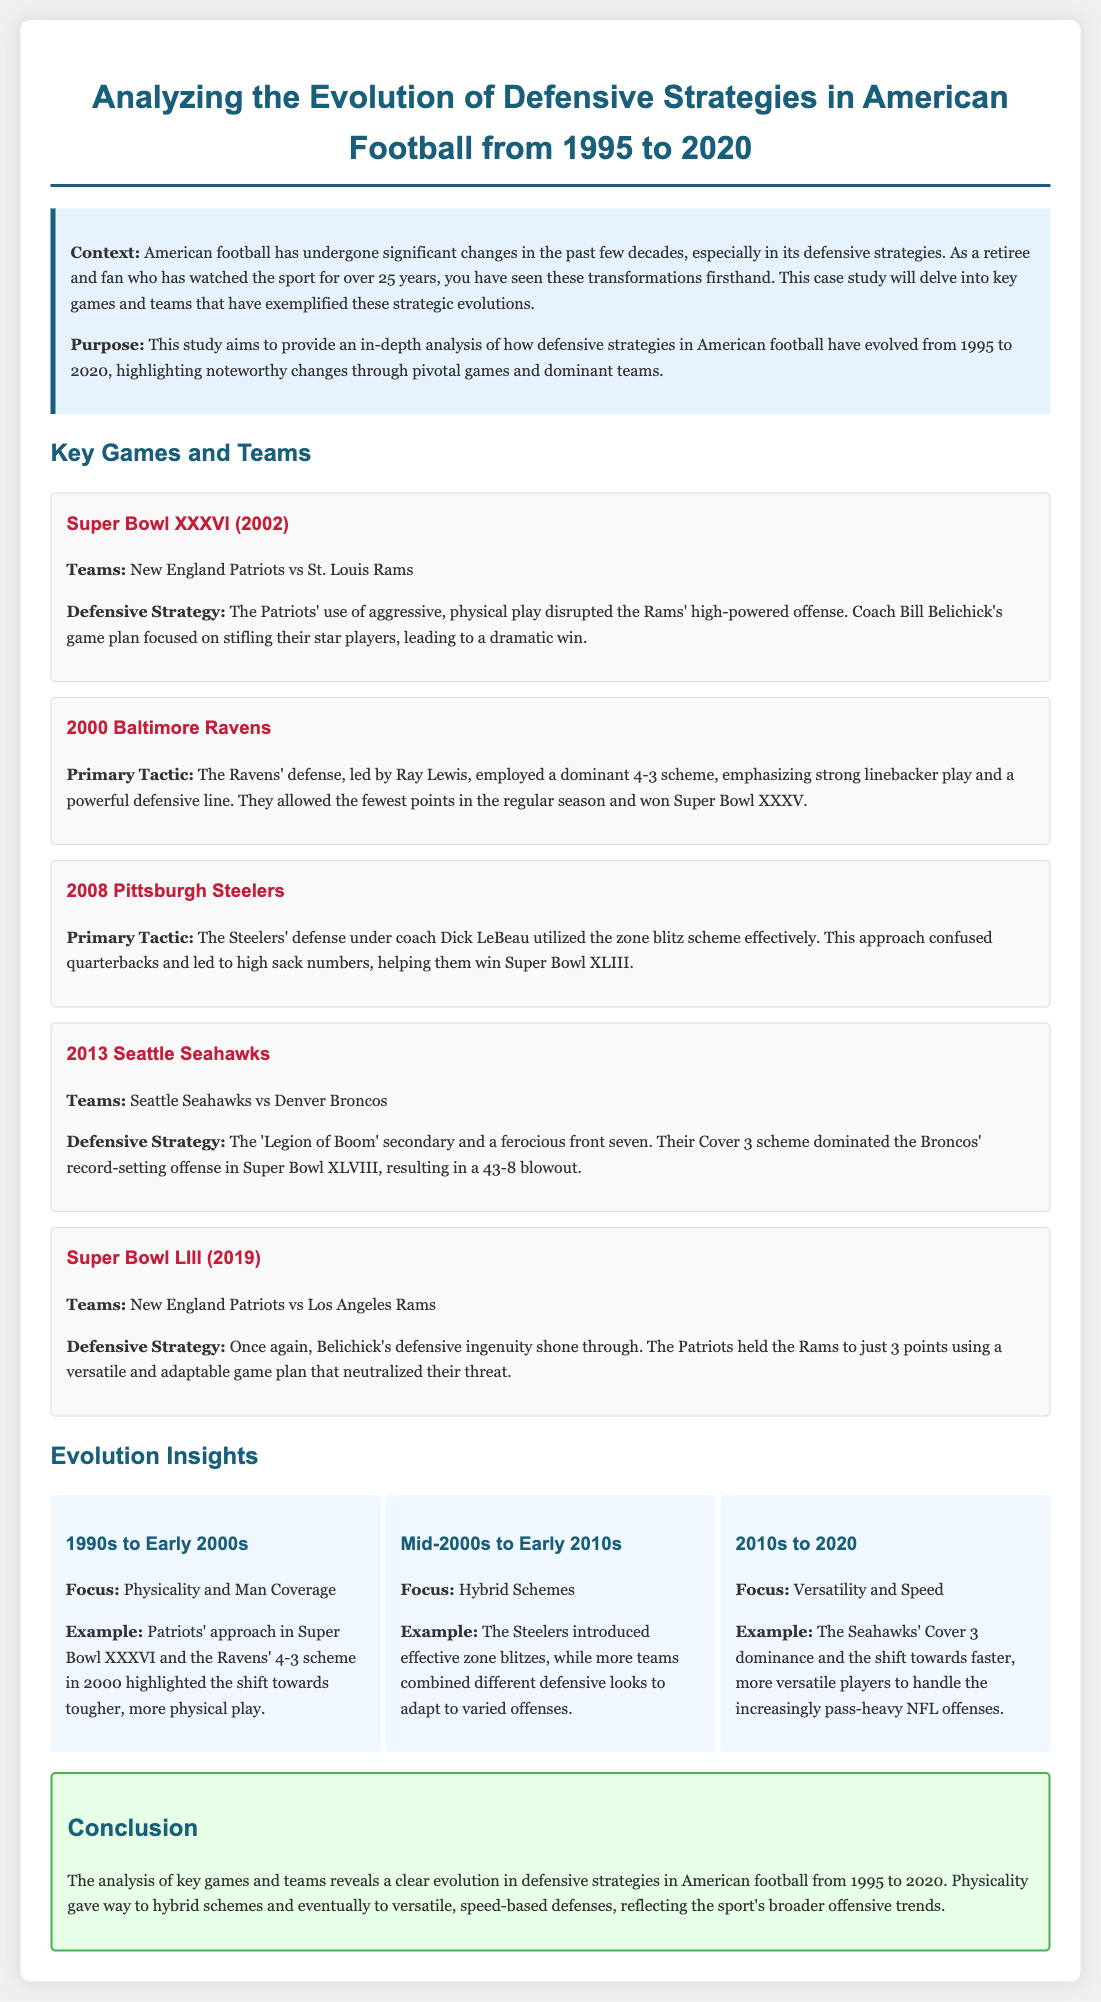what was the defensive strategy used in Super Bowl XXXVI? The Patriots' use of aggressive, physical play disrupted the Rams' high-powered offense.
Answer: aggressive, physical play who was the coach of the 2000 Baltimore Ravens? The document mentions Ray Lewis as a key player, while the coach is not directly named.
Answer: not specified which team employed the zone blitz scheme in 2008? The Steelers' defense under coach Dick LeBeau utilized the zone blitz scheme effectively.
Answer: Pittsburgh Steelers what is a key focus of defensive strategies from the 2010s to 2020? The focus during this period was on versatility and speed.
Answer: versatility and speed what notable defense did the Seahawks use in Super Bowl XLVIII? The 'Legion of Boom' secondary and a ferocious front seven.
Answer: Cover 3 scheme how many points did the Patriots hold the Rams to in Super Bowl LIII? The Patriots held the Rams to just 3 points.
Answer: 3 points which defensive strategy highlighted the 1990s to Early 2000s? The focus during this period was on physicality and man coverage.
Answer: physicality and man coverage what game exemplified the Ravens' dominant 4-3 scheme? The Ravens allowed the fewest points in the regular season and won Super Bowl XXXV.
Answer: Super Bowl XXXV who was the head coach of the Patriots during Super Bowl LIII? The document states that Belichick's defensive ingenuity shone through in this game.
Answer: Bill Belichick 